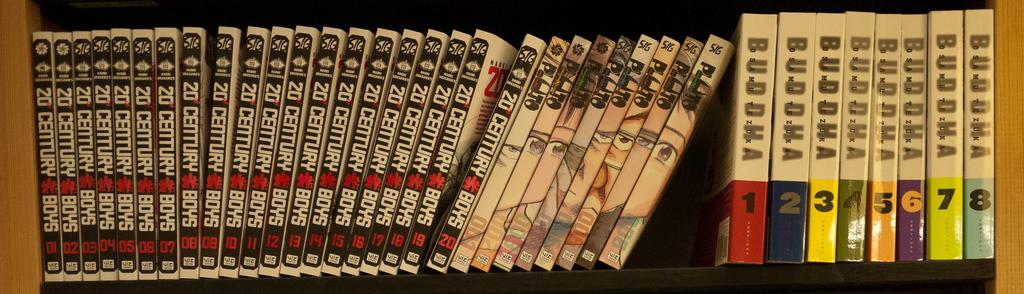Provide a one-sentence caption for the provided image. A set of black books with white writing on a shelf are numbered from one through twenty. 